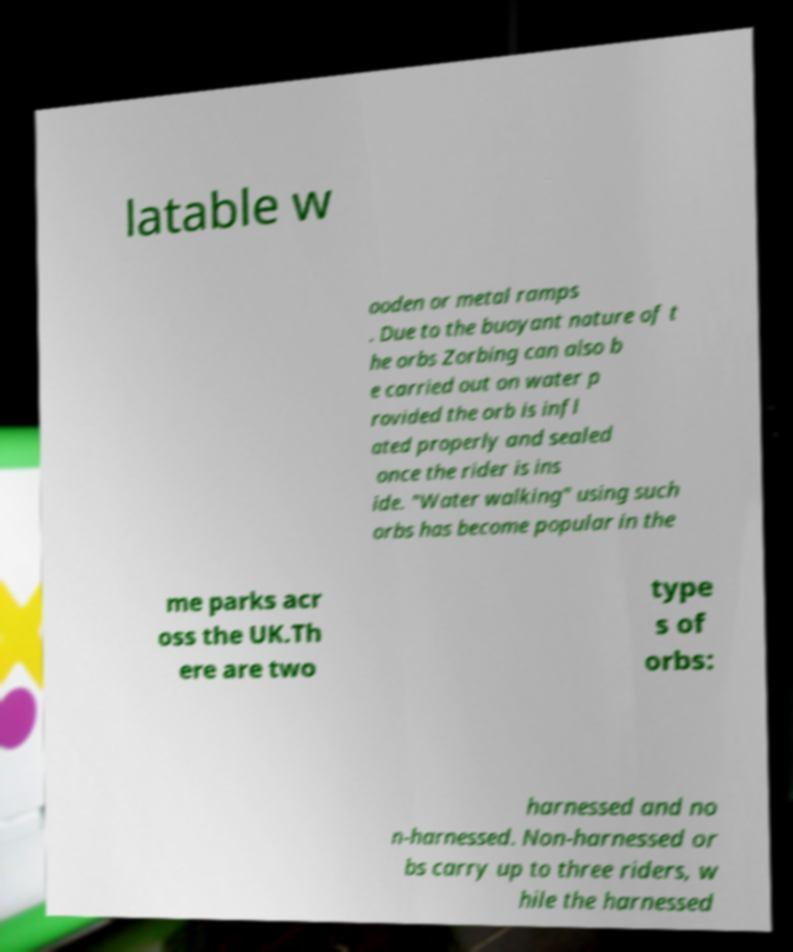Could you assist in decoding the text presented in this image and type it out clearly? latable w ooden or metal ramps . Due to the buoyant nature of t he orbs Zorbing can also b e carried out on water p rovided the orb is infl ated properly and sealed once the rider is ins ide. "Water walking" using such orbs has become popular in the me parks acr oss the UK.Th ere are two type s of orbs: harnessed and no n-harnessed. Non-harnessed or bs carry up to three riders, w hile the harnessed 